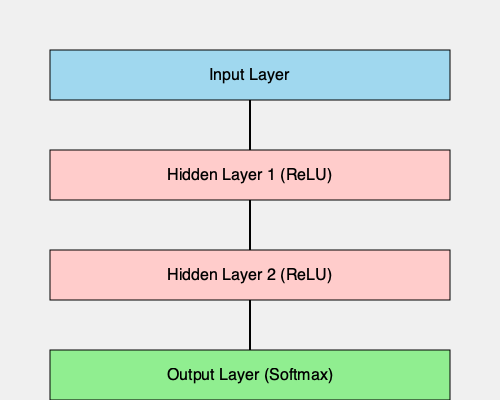Given the neural network architecture shown in the flowchart, which activation function is likely used in the hidden layers, and what is the purpose of using a different activation function (Softmax) in the output layer? 1. Hidden Layer Activation:
   - The flowchart shows two hidden layers using ReLU (Rectified Linear Unit) activation.
   - ReLU is defined as $f(x) = \max(0, x)$.
   - It's commonly used in hidden layers due to its simplicity and effectiveness in addressing the vanishing gradient problem.

2. Output Layer Activation:
   - The output layer uses the Softmax activation function.
   - Softmax is defined as $\sigma(z)_i = \frac{e^{z_i}}{\sum_{j=1}^K e^{z_j}}$ for $i = 1, ..., K$.
   - It's typically used in multi-class classification problems.

3. Purpose of Softmax in the Output Layer:
   - Softmax converts the raw output scores into probabilities.
   - It ensures that the sum of all output probabilities equals 1.
   - This allows for easy interpretation of the network's predictions as class probabilities.

4. Difference in Activation Functions:
   - ReLU in hidden layers: Introduces non-linearity, allows for complex feature learning.
   - Softmax in output layer: Provides normalized probability distribution across classes.

5. Advantages of this Architecture:
   - ReLU allows for efficient training of deep networks.
   - Softmax enables clear probabilistic interpretation of outputs.
   - This combination is effective for many classification tasks.
Answer: ReLU in hidden layers for non-linearity; Softmax in output layer for probabilistic multi-class classification. 